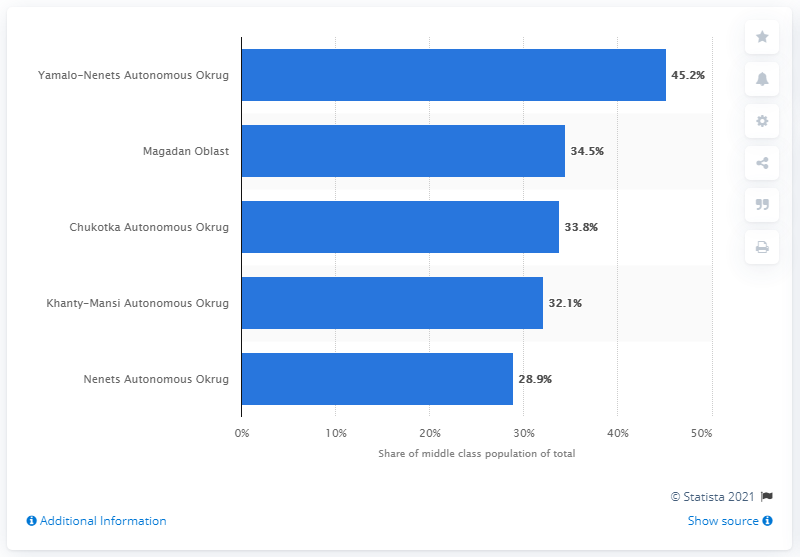List a handful of essential elements in this visual. In Magadan Oblast, nearly 35% of the population received the same status between June 2018 and June 2019. The highest share of the middle class was observed in Yamalo-Nenets Autonomous Okrug among federal subjects. 